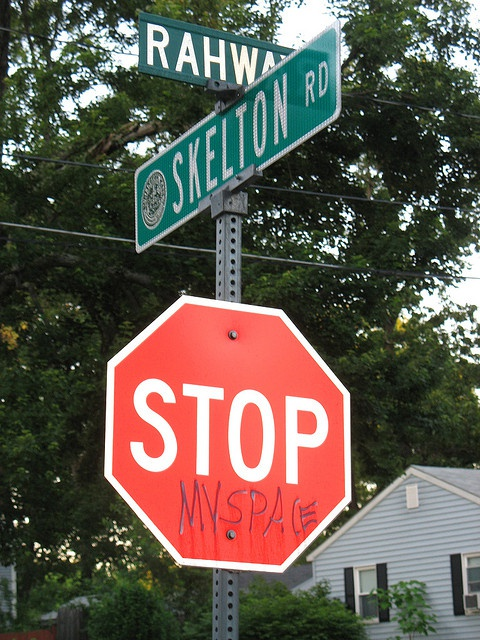Describe the objects in this image and their specific colors. I can see a stop sign in black, salmon, white, and red tones in this image. 